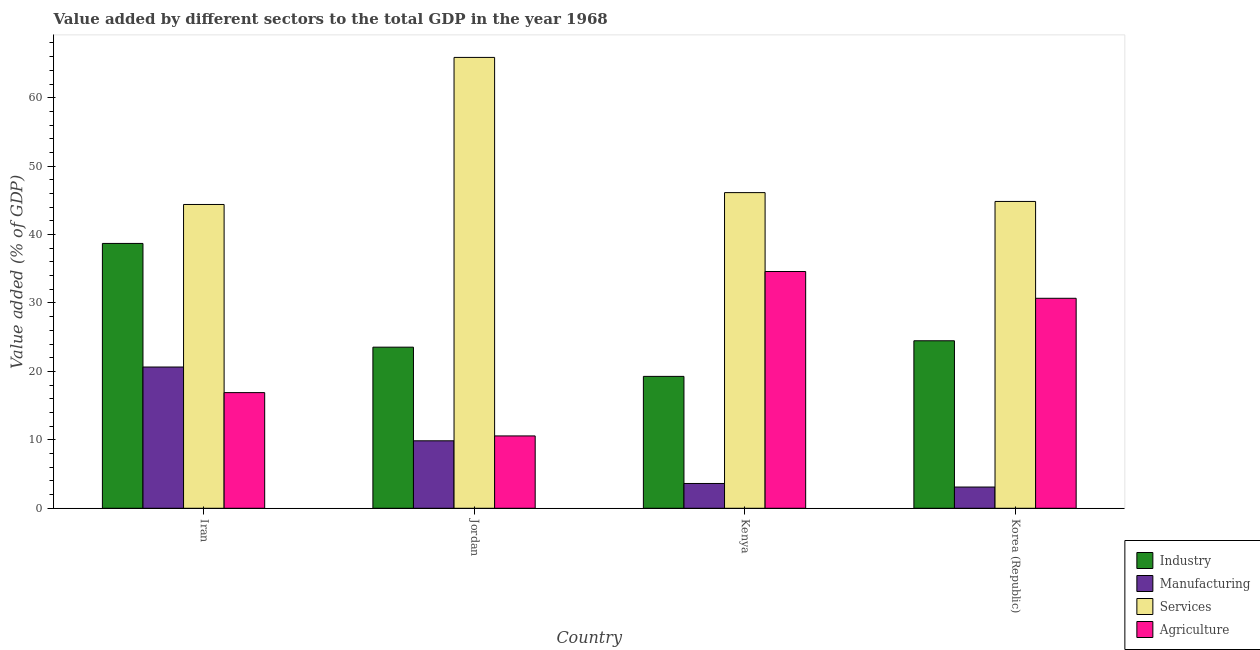How many different coloured bars are there?
Provide a short and direct response. 4. Are the number of bars per tick equal to the number of legend labels?
Provide a short and direct response. Yes. What is the label of the 1st group of bars from the left?
Your answer should be very brief. Iran. What is the value added by agricultural sector in Iran?
Provide a short and direct response. 16.9. Across all countries, what is the maximum value added by industrial sector?
Provide a succinct answer. 38.7. Across all countries, what is the minimum value added by industrial sector?
Offer a very short reply. 19.27. In which country was the value added by services sector maximum?
Your answer should be compact. Jordan. In which country was the value added by industrial sector minimum?
Offer a very short reply. Kenya. What is the total value added by industrial sector in the graph?
Your answer should be very brief. 106. What is the difference between the value added by industrial sector in Iran and that in Kenya?
Offer a very short reply. 19.43. What is the difference between the value added by industrial sector in Iran and the value added by manufacturing sector in Kenya?
Make the answer very short. 35.08. What is the average value added by manufacturing sector per country?
Your response must be concise. 9.31. What is the difference between the value added by agricultural sector and value added by manufacturing sector in Korea (Republic)?
Offer a very short reply. 27.58. In how many countries, is the value added by manufacturing sector greater than 10 %?
Give a very brief answer. 1. What is the ratio of the value added by industrial sector in Iran to that in Korea (Republic)?
Your answer should be compact. 1.58. What is the difference between the highest and the second highest value added by services sector?
Your answer should be very brief. 19.76. What is the difference between the highest and the lowest value added by services sector?
Keep it short and to the point. 21.49. Is it the case that in every country, the sum of the value added by manufacturing sector and value added by industrial sector is greater than the sum of value added by agricultural sector and value added by services sector?
Your answer should be very brief. No. What does the 3rd bar from the left in Korea (Republic) represents?
Your answer should be compact. Services. What does the 3rd bar from the right in Korea (Republic) represents?
Provide a short and direct response. Manufacturing. How many bars are there?
Provide a short and direct response. 16. Are all the bars in the graph horizontal?
Your response must be concise. No. What is the difference between two consecutive major ticks on the Y-axis?
Your response must be concise. 10. Does the graph contain any zero values?
Offer a terse response. No. Does the graph contain grids?
Make the answer very short. No. What is the title of the graph?
Give a very brief answer. Value added by different sectors to the total GDP in the year 1968. What is the label or title of the X-axis?
Your response must be concise. Country. What is the label or title of the Y-axis?
Your response must be concise. Value added (% of GDP). What is the Value added (% of GDP) in Industry in Iran?
Offer a terse response. 38.7. What is the Value added (% of GDP) of Manufacturing in Iran?
Your answer should be compact. 20.64. What is the Value added (% of GDP) of Services in Iran?
Offer a very short reply. 44.39. What is the Value added (% of GDP) of Agriculture in Iran?
Offer a terse response. 16.9. What is the Value added (% of GDP) in Industry in Jordan?
Make the answer very short. 23.54. What is the Value added (% of GDP) in Manufacturing in Jordan?
Make the answer very short. 9.86. What is the Value added (% of GDP) in Services in Jordan?
Your answer should be compact. 65.89. What is the Value added (% of GDP) in Agriculture in Jordan?
Your answer should be compact. 10.57. What is the Value added (% of GDP) of Industry in Kenya?
Your response must be concise. 19.27. What is the Value added (% of GDP) of Manufacturing in Kenya?
Your answer should be very brief. 3.62. What is the Value added (% of GDP) of Services in Kenya?
Make the answer very short. 46.13. What is the Value added (% of GDP) of Agriculture in Kenya?
Offer a terse response. 34.6. What is the Value added (% of GDP) in Industry in Korea (Republic)?
Ensure brevity in your answer.  24.48. What is the Value added (% of GDP) of Manufacturing in Korea (Republic)?
Give a very brief answer. 3.1. What is the Value added (% of GDP) of Services in Korea (Republic)?
Your answer should be very brief. 44.84. What is the Value added (% of GDP) of Agriculture in Korea (Republic)?
Make the answer very short. 30.68. Across all countries, what is the maximum Value added (% of GDP) in Industry?
Give a very brief answer. 38.7. Across all countries, what is the maximum Value added (% of GDP) of Manufacturing?
Your answer should be compact. 20.64. Across all countries, what is the maximum Value added (% of GDP) of Services?
Make the answer very short. 65.89. Across all countries, what is the maximum Value added (% of GDP) of Agriculture?
Provide a succinct answer. 34.6. Across all countries, what is the minimum Value added (% of GDP) in Industry?
Give a very brief answer. 19.27. Across all countries, what is the minimum Value added (% of GDP) in Manufacturing?
Offer a terse response. 3.1. Across all countries, what is the minimum Value added (% of GDP) of Services?
Offer a very short reply. 44.39. Across all countries, what is the minimum Value added (% of GDP) in Agriculture?
Keep it short and to the point. 10.57. What is the total Value added (% of GDP) of Industry in the graph?
Keep it short and to the point. 106. What is the total Value added (% of GDP) in Manufacturing in the graph?
Provide a succinct answer. 37.23. What is the total Value added (% of GDP) of Services in the graph?
Your response must be concise. 201.25. What is the total Value added (% of GDP) of Agriculture in the graph?
Give a very brief answer. 92.76. What is the difference between the Value added (% of GDP) of Industry in Iran and that in Jordan?
Provide a short and direct response. 15.16. What is the difference between the Value added (% of GDP) of Manufacturing in Iran and that in Jordan?
Offer a very short reply. 10.78. What is the difference between the Value added (% of GDP) of Services in Iran and that in Jordan?
Keep it short and to the point. -21.49. What is the difference between the Value added (% of GDP) in Agriculture in Iran and that in Jordan?
Make the answer very short. 6.33. What is the difference between the Value added (% of GDP) of Industry in Iran and that in Kenya?
Provide a succinct answer. 19.43. What is the difference between the Value added (% of GDP) of Manufacturing in Iran and that in Kenya?
Offer a very short reply. 17.02. What is the difference between the Value added (% of GDP) in Services in Iran and that in Kenya?
Offer a very short reply. -1.73. What is the difference between the Value added (% of GDP) of Agriculture in Iran and that in Kenya?
Ensure brevity in your answer.  -17.7. What is the difference between the Value added (% of GDP) of Industry in Iran and that in Korea (Republic)?
Make the answer very short. 14.23. What is the difference between the Value added (% of GDP) in Manufacturing in Iran and that in Korea (Republic)?
Provide a succinct answer. 17.54. What is the difference between the Value added (% of GDP) of Services in Iran and that in Korea (Republic)?
Give a very brief answer. -0.44. What is the difference between the Value added (% of GDP) of Agriculture in Iran and that in Korea (Republic)?
Give a very brief answer. -13.78. What is the difference between the Value added (% of GDP) of Industry in Jordan and that in Kenya?
Provide a succinct answer. 4.27. What is the difference between the Value added (% of GDP) of Manufacturing in Jordan and that in Kenya?
Your response must be concise. 6.24. What is the difference between the Value added (% of GDP) of Services in Jordan and that in Kenya?
Provide a succinct answer. 19.76. What is the difference between the Value added (% of GDP) in Agriculture in Jordan and that in Kenya?
Provide a short and direct response. -24.03. What is the difference between the Value added (% of GDP) in Industry in Jordan and that in Korea (Republic)?
Provide a succinct answer. -0.94. What is the difference between the Value added (% of GDP) in Manufacturing in Jordan and that in Korea (Republic)?
Provide a short and direct response. 6.76. What is the difference between the Value added (% of GDP) in Services in Jordan and that in Korea (Republic)?
Make the answer very short. 21.05. What is the difference between the Value added (% of GDP) of Agriculture in Jordan and that in Korea (Republic)?
Provide a succinct answer. -20.11. What is the difference between the Value added (% of GDP) in Industry in Kenya and that in Korea (Republic)?
Provide a short and direct response. -5.2. What is the difference between the Value added (% of GDP) of Manufacturing in Kenya and that in Korea (Republic)?
Ensure brevity in your answer.  0.52. What is the difference between the Value added (% of GDP) in Services in Kenya and that in Korea (Republic)?
Your answer should be very brief. 1.29. What is the difference between the Value added (% of GDP) in Agriculture in Kenya and that in Korea (Republic)?
Your answer should be very brief. 3.91. What is the difference between the Value added (% of GDP) in Industry in Iran and the Value added (% of GDP) in Manufacturing in Jordan?
Your answer should be compact. 28.84. What is the difference between the Value added (% of GDP) of Industry in Iran and the Value added (% of GDP) of Services in Jordan?
Keep it short and to the point. -27.18. What is the difference between the Value added (% of GDP) in Industry in Iran and the Value added (% of GDP) in Agriculture in Jordan?
Make the answer very short. 28.13. What is the difference between the Value added (% of GDP) in Manufacturing in Iran and the Value added (% of GDP) in Services in Jordan?
Offer a very short reply. -45.24. What is the difference between the Value added (% of GDP) in Manufacturing in Iran and the Value added (% of GDP) in Agriculture in Jordan?
Your answer should be compact. 10.07. What is the difference between the Value added (% of GDP) of Services in Iran and the Value added (% of GDP) of Agriculture in Jordan?
Give a very brief answer. 33.82. What is the difference between the Value added (% of GDP) in Industry in Iran and the Value added (% of GDP) in Manufacturing in Kenya?
Make the answer very short. 35.08. What is the difference between the Value added (% of GDP) in Industry in Iran and the Value added (% of GDP) in Services in Kenya?
Your answer should be compact. -7.42. What is the difference between the Value added (% of GDP) in Industry in Iran and the Value added (% of GDP) in Agriculture in Kenya?
Your answer should be compact. 4.1. What is the difference between the Value added (% of GDP) in Manufacturing in Iran and the Value added (% of GDP) in Services in Kenya?
Provide a short and direct response. -25.49. What is the difference between the Value added (% of GDP) in Manufacturing in Iran and the Value added (% of GDP) in Agriculture in Kenya?
Ensure brevity in your answer.  -13.96. What is the difference between the Value added (% of GDP) of Services in Iran and the Value added (% of GDP) of Agriculture in Kenya?
Your answer should be compact. 9.8. What is the difference between the Value added (% of GDP) in Industry in Iran and the Value added (% of GDP) in Manufacturing in Korea (Republic)?
Your answer should be very brief. 35.6. What is the difference between the Value added (% of GDP) in Industry in Iran and the Value added (% of GDP) in Services in Korea (Republic)?
Ensure brevity in your answer.  -6.13. What is the difference between the Value added (% of GDP) of Industry in Iran and the Value added (% of GDP) of Agriculture in Korea (Republic)?
Make the answer very short. 8.02. What is the difference between the Value added (% of GDP) in Manufacturing in Iran and the Value added (% of GDP) in Services in Korea (Republic)?
Make the answer very short. -24.2. What is the difference between the Value added (% of GDP) of Manufacturing in Iran and the Value added (% of GDP) of Agriculture in Korea (Republic)?
Ensure brevity in your answer.  -10.04. What is the difference between the Value added (% of GDP) in Services in Iran and the Value added (% of GDP) in Agriculture in Korea (Republic)?
Your answer should be compact. 13.71. What is the difference between the Value added (% of GDP) of Industry in Jordan and the Value added (% of GDP) of Manufacturing in Kenya?
Your response must be concise. 19.92. What is the difference between the Value added (% of GDP) of Industry in Jordan and the Value added (% of GDP) of Services in Kenya?
Your answer should be compact. -22.59. What is the difference between the Value added (% of GDP) in Industry in Jordan and the Value added (% of GDP) in Agriculture in Kenya?
Your answer should be very brief. -11.06. What is the difference between the Value added (% of GDP) of Manufacturing in Jordan and the Value added (% of GDP) of Services in Kenya?
Offer a terse response. -36.27. What is the difference between the Value added (% of GDP) in Manufacturing in Jordan and the Value added (% of GDP) in Agriculture in Kenya?
Provide a succinct answer. -24.74. What is the difference between the Value added (% of GDP) in Services in Jordan and the Value added (% of GDP) in Agriculture in Kenya?
Give a very brief answer. 31.29. What is the difference between the Value added (% of GDP) in Industry in Jordan and the Value added (% of GDP) in Manufacturing in Korea (Republic)?
Ensure brevity in your answer.  20.44. What is the difference between the Value added (% of GDP) of Industry in Jordan and the Value added (% of GDP) of Services in Korea (Republic)?
Keep it short and to the point. -21.3. What is the difference between the Value added (% of GDP) in Industry in Jordan and the Value added (% of GDP) in Agriculture in Korea (Republic)?
Make the answer very short. -7.14. What is the difference between the Value added (% of GDP) in Manufacturing in Jordan and the Value added (% of GDP) in Services in Korea (Republic)?
Offer a very short reply. -34.98. What is the difference between the Value added (% of GDP) in Manufacturing in Jordan and the Value added (% of GDP) in Agriculture in Korea (Republic)?
Offer a very short reply. -20.82. What is the difference between the Value added (% of GDP) of Services in Jordan and the Value added (% of GDP) of Agriculture in Korea (Republic)?
Give a very brief answer. 35.2. What is the difference between the Value added (% of GDP) in Industry in Kenya and the Value added (% of GDP) in Manufacturing in Korea (Republic)?
Make the answer very short. 16.17. What is the difference between the Value added (% of GDP) in Industry in Kenya and the Value added (% of GDP) in Services in Korea (Republic)?
Offer a very short reply. -25.56. What is the difference between the Value added (% of GDP) in Industry in Kenya and the Value added (% of GDP) in Agriculture in Korea (Republic)?
Provide a short and direct response. -11.41. What is the difference between the Value added (% of GDP) of Manufacturing in Kenya and the Value added (% of GDP) of Services in Korea (Republic)?
Ensure brevity in your answer.  -41.21. What is the difference between the Value added (% of GDP) of Manufacturing in Kenya and the Value added (% of GDP) of Agriculture in Korea (Republic)?
Offer a terse response. -27.06. What is the difference between the Value added (% of GDP) in Services in Kenya and the Value added (% of GDP) in Agriculture in Korea (Republic)?
Your answer should be very brief. 15.44. What is the average Value added (% of GDP) in Industry per country?
Your answer should be compact. 26.5. What is the average Value added (% of GDP) of Manufacturing per country?
Keep it short and to the point. 9.31. What is the average Value added (% of GDP) of Services per country?
Offer a very short reply. 50.31. What is the average Value added (% of GDP) of Agriculture per country?
Keep it short and to the point. 23.19. What is the difference between the Value added (% of GDP) in Industry and Value added (% of GDP) in Manufacturing in Iran?
Keep it short and to the point. 18.06. What is the difference between the Value added (% of GDP) of Industry and Value added (% of GDP) of Services in Iran?
Make the answer very short. -5.69. What is the difference between the Value added (% of GDP) of Industry and Value added (% of GDP) of Agriculture in Iran?
Offer a terse response. 21.8. What is the difference between the Value added (% of GDP) in Manufacturing and Value added (% of GDP) in Services in Iran?
Offer a terse response. -23.75. What is the difference between the Value added (% of GDP) in Manufacturing and Value added (% of GDP) in Agriculture in Iran?
Ensure brevity in your answer.  3.74. What is the difference between the Value added (% of GDP) in Services and Value added (% of GDP) in Agriculture in Iran?
Provide a succinct answer. 27.49. What is the difference between the Value added (% of GDP) in Industry and Value added (% of GDP) in Manufacturing in Jordan?
Your response must be concise. 13.68. What is the difference between the Value added (% of GDP) of Industry and Value added (% of GDP) of Services in Jordan?
Provide a succinct answer. -42.34. What is the difference between the Value added (% of GDP) of Industry and Value added (% of GDP) of Agriculture in Jordan?
Provide a succinct answer. 12.97. What is the difference between the Value added (% of GDP) of Manufacturing and Value added (% of GDP) of Services in Jordan?
Make the answer very short. -56.03. What is the difference between the Value added (% of GDP) in Manufacturing and Value added (% of GDP) in Agriculture in Jordan?
Your answer should be compact. -0.71. What is the difference between the Value added (% of GDP) of Services and Value added (% of GDP) of Agriculture in Jordan?
Make the answer very short. 55.31. What is the difference between the Value added (% of GDP) in Industry and Value added (% of GDP) in Manufacturing in Kenya?
Offer a terse response. 15.65. What is the difference between the Value added (% of GDP) in Industry and Value added (% of GDP) in Services in Kenya?
Your answer should be very brief. -26.85. What is the difference between the Value added (% of GDP) in Industry and Value added (% of GDP) in Agriculture in Kenya?
Make the answer very short. -15.33. What is the difference between the Value added (% of GDP) of Manufacturing and Value added (% of GDP) of Services in Kenya?
Your response must be concise. -42.5. What is the difference between the Value added (% of GDP) of Manufacturing and Value added (% of GDP) of Agriculture in Kenya?
Provide a succinct answer. -30.98. What is the difference between the Value added (% of GDP) of Services and Value added (% of GDP) of Agriculture in Kenya?
Keep it short and to the point. 11.53. What is the difference between the Value added (% of GDP) in Industry and Value added (% of GDP) in Manufacturing in Korea (Republic)?
Give a very brief answer. 21.37. What is the difference between the Value added (% of GDP) in Industry and Value added (% of GDP) in Services in Korea (Republic)?
Provide a succinct answer. -20.36. What is the difference between the Value added (% of GDP) in Industry and Value added (% of GDP) in Agriculture in Korea (Republic)?
Give a very brief answer. -6.21. What is the difference between the Value added (% of GDP) in Manufacturing and Value added (% of GDP) in Services in Korea (Republic)?
Offer a terse response. -41.73. What is the difference between the Value added (% of GDP) of Manufacturing and Value added (% of GDP) of Agriculture in Korea (Republic)?
Provide a short and direct response. -27.58. What is the difference between the Value added (% of GDP) of Services and Value added (% of GDP) of Agriculture in Korea (Republic)?
Offer a terse response. 14.15. What is the ratio of the Value added (% of GDP) of Industry in Iran to that in Jordan?
Provide a succinct answer. 1.64. What is the ratio of the Value added (% of GDP) of Manufacturing in Iran to that in Jordan?
Offer a very short reply. 2.09. What is the ratio of the Value added (% of GDP) in Services in Iran to that in Jordan?
Your answer should be very brief. 0.67. What is the ratio of the Value added (% of GDP) of Agriculture in Iran to that in Jordan?
Your answer should be very brief. 1.6. What is the ratio of the Value added (% of GDP) of Industry in Iran to that in Kenya?
Offer a terse response. 2.01. What is the ratio of the Value added (% of GDP) in Manufacturing in Iran to that in Kenya?
Your answer should be very brief. 5.7. What is the ratio of the Value added (% of GDP) in Services in Iran to that in Kenya?
Offer a terse response. 0.96. What is the ratio of the Value added (% of GDP) in Agriculture in Iran to that in Kenya?
Your answer should be very brief. 0.49. What is the ratio of the Value added (% of GDP) of Industry in Iran to that in Korea (Republic)?
Ensure brevity in your answer.  1.58. What is the ratio of the Value added (% of GDP) of Manufacturing in Iran to that in Korea (Republic)?
Keep it short and to the point. 6.65. What is the ratio of the Value added (% of GDP) in Services in Iran to that in Korea (Republic)?
Give a very brief answer. 0.99. What is the ratio of the Value added (% of GDP) of Agriculture in Iran to that in Korea (Republic)?
Give a very brief answer. 0.55. What is the ratio of the Value added (% of GDP) of Industry in Jordan to that in Kenya?
Provide a succinct answer. 1.22. What is the ratio of the Value added (% of GDP) in Manufacturing in Jordan to that in Kenya?
Make the answer very short. 2.72. What is the ratio of the Value added (% of GDP) in Services in Jordan to that in Kenya?
Give a very brief answer. 1.43. What is the ratio of the Value added (% of GDP) of Agriculture in Jordan to that in Kenya?
Your answer should be compact. 0.31. What is the ratio of the Value added (% of GDP) in Industry in Jordan to that in Korea (Republic)?
Offer a very short reply. 0.96. What is the ratio of the Value added (% of GDP) of Manufacturing in Jordan to that in Korea (Republic)?
Your answer should be very brief. 3.18. What is the ratio of the Value added (% of GDP) of Services in Jordan to that in Korea (Republic)?
Keep it short and to the point. 1.47. What is the ratio of the Value added (% of GDP) of Agriculture in Jordan to that in Korea (Republic)?
Keep it short and to the point. 0.34. What is the ratio of the Value added (% of GDP) in Industry in Kenya to that in Korea (Republic)?
Offer a very short reply. 0.79. What is the ratio of the Value added (% of GDP) in Manufacturing in Kenya to that in Korea (Republic)?
Ensure brevity in your answer.  1.17. What is the ratio of the Value added (% of GDP) of Services in Kenya to that in Korea (Republic)?
Your answer should be compact. 1.03. What is the ratio of the Value added (% of GDP) in Agriculture in Kenya to that in Korea (Republic)?
Your answer should be very brief. 1.13. What is the difference between the highest and the second highest Value added (% of GDP) in Industry?
Your answer should be compact. 14.23. What is the difference between the highest and the second highest Value added (% of GDP) of Manufacturing?
Give a very brief answer. 10.78. What is the difference between the highest and the second highest Value added (% of GDP) in Services?
Your answer should be very brief. 19.76. What is the difference between the highest and the second highest Value added (% of GDP) of Agriculture?
Provide a short and direct response. 3.91. What is the difference between the highest and the lowest Value added (% of GDP) in Industry?
Keep it short and to the point. 19.43. What is the difference between the highest and the lowest Value added (% of GDP) in Manufacturing?
Your answer should be very brief. 17.54. What is the difference between the highest and the lowest Value added (% of GDP) of Services?
Your answer should be compact. 21.49. What is the difference between the highest and the lowest Value added (% of GDP) of Agriculture?
Ensure brevity in your answer.  24.03. 